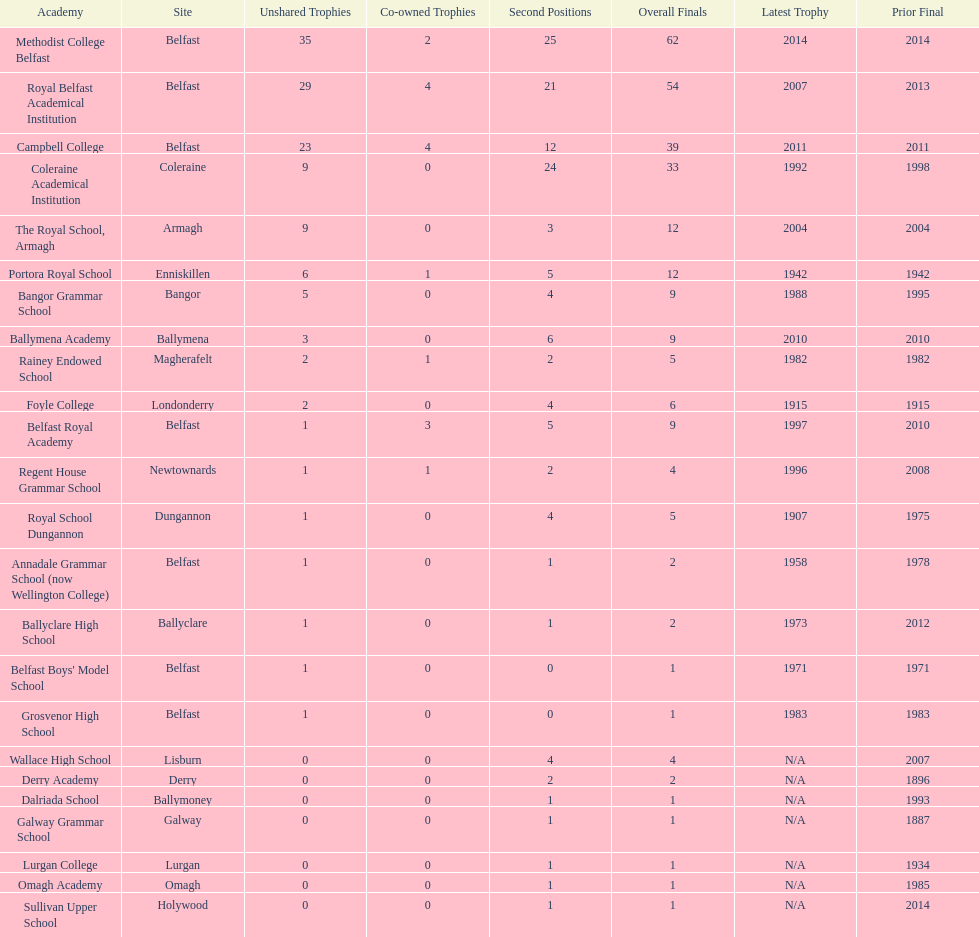Who has the most recent title win, campbell college or regent house grammar school? Campbell College. 